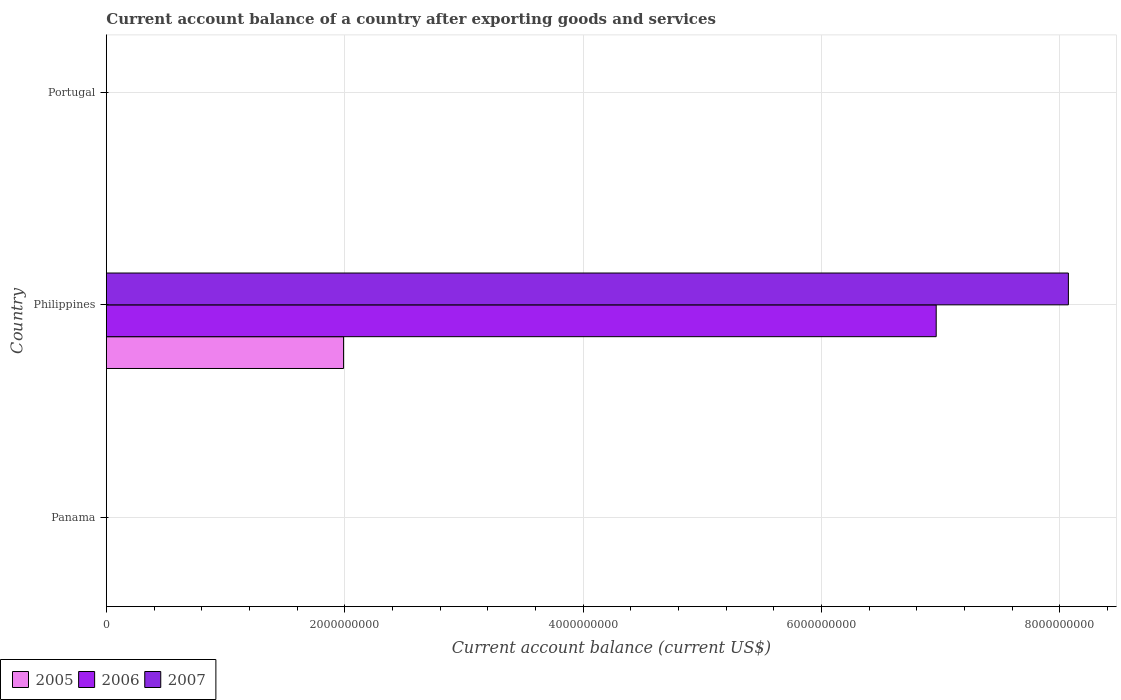How many different coloured bars are there?
Provide a short and direct response. 3. Are the number of bars on each tick of the Y-axis equal?
Provide a short and direct response. No. How many bars are there on the 3rd tick from the top?
Your response must be concise. 0. How many bars are there on the 2nd tick from the bottom?
Provide a short and direct response. 3. What is the account balance in 2005 in Portugal?
Your answer should be very brief. 0. Across all countries, what is the maximum account balance in 2006?
Offer a very short reply. 6.96e+09. In which country was the account balance in 2006 maximum?
Your answer should be very brief. Philippines. What is the total account balance in 2006 in the graph?
Make the answer very short. 6.96e+09. What is the average account balance in 2007 per country?
Give a very brief answer. 2.69e+09. What is the difference between the account balance in 2006 and account balance in 2005 in Philippines?
Provide a succinct answer. 4.97e+09. What is the difference between the highest and the lowest account balance in 2005?
Your answer should be compact. 1.99e+09. In how many countries, is the account balance in 2006 greater than the average account balance in 2006 taken over all countries?
Your answer should be very brief. 1. Is it the case that in every country, the sum of the account balance in 2007 and account balance in 2005 is greater than the account balance in 2006?
Make the answer very short. No. Are all the bars in the graph horizontal?
Provide a short and direct response. Yes. How many countries are there in the graph?
Your answer should be compact. 3. Does the graph contain grids?
Provide a short and direct response. Yes. How many legend labels are there?
Provide a succinct answer. 3. How are the legend labels stacked?
Keep it short and to the point. Horizontal. What is the title of the graph?
Your answer should be compact. Current account balance of a country after exporting goods and services. What is the label or title of the X-axis?
Make the answer very short. Current account balance (current US$). What is the Current account balance (current US$) in 2005 in Panama?
Provide a succinct answer. 0. What is the Current account balance (current US$) of 2007 in Panama?
Ensure brevity in your answer.  0. What is the Current account balance (current US$) of 2005 in Philippines?
Make the answer very short. 1.99e+09. What is the Current account balance (current US$) of 2006 in Philippines?
Offer a very short reply. 6.96e+09. What is the Current account balance (current US$) of 2007 in Philippines?
Ensure brevity in your answer.  8.07e+09. What is the Current account balance (current US$) in 2005 in Portugal?
Your response must be concise. 0. Across all countries, what is the maximum Current account balance (current US$) of 2005?
Offer a terse response. 1.99e+09. Across all countries, what is the maximum Current account balance (current US$) in 2006?
Your answer should be compact. 6.96e+09. Across all countries, what is the maximum Current account balance (current US$) of 2007?
Your answer should be very brief. 8.07e+09. Across all countries, what is the minimum Current account balance (current US$) of 2005?
Keep it short and to the point. 0. Across all countries, what is the minimum Current account balance (current US$) in 2007?
Make the answer very short. 0. What is the total Current account balance (current US$) of 2005 in the graph?
Your response must be concise. 1.99e+09. What is the total Current account balance (current US$) in 2006 in the graph?
Your response must be concise. 6.96e+09. What is the total Current account balance (current US$) of 2007 in the graph?
Provide a succinct answer. 8.07e+09. What is the average Current account balance (current US$) in 2005 per country?
Offer a very short reply. 6.63e+08. What is the average Current account balance (current US$) in 2006 per country?
Offer a very short reply. 2.32e+09. What is the average Current account balance (current US$) of 2007 per country?
Your response must be concise. 2.69e+09. What is the difference between the Current account balance (current US$) of 2005 and Current account balance (current US$) of 2006 in Philippines?
Provide a succinct answer. -4.97e+09. What is the difference between the Current account balance (current US$) of 2005 and Current account balance (current US$) of 2007 in Philippines?
Provide a short and direct response. -6.08e+09. What is the difference between the Current account balance (current US$) of 2006 and Current account balance (current US$) of 2007 in Philippines?
Provide a short and direct response. -1.11e+09. What is the difference between the highest and the lowest Current account balance (current US$) in 2005?
Keep it short and to the point. 1.99e+09. What is the difference between the highest and the lowest Current account balance (current US$) of 2006?
Your response must be concise. 6.96e+09. What is the difference between the highest and the lowest Current account balance (current US$) of 2007?
Offer a very short reply. 8.07e+09. 